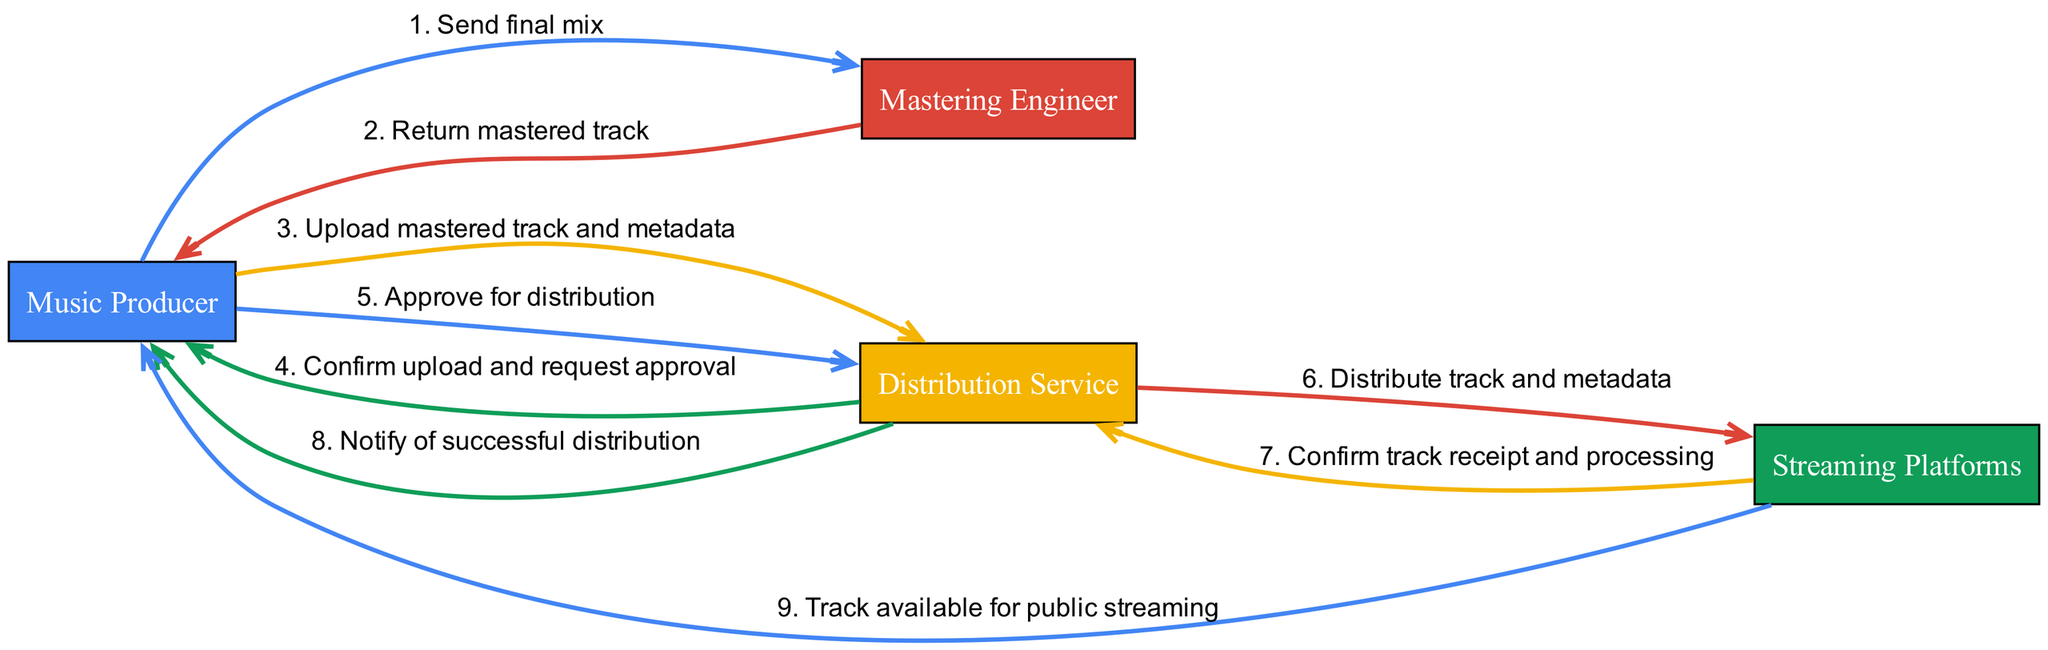What is the first action in the sequence? The first action in the sequence is identified by looking at the first entry in the sequence list. It states that the Music Producer sends the final mix to the Mastering Engineer, marking the beginning of the process.
Answer: Send final mix How many actors are involved in the diagram? To find the number of actors, we can simply count the entries in the "actors" list provided in the data. There are four distinct actors in this diagram.
Answer: 4 Which actor receives the mastered track? By examining the sequence of actions, the second action indicates that the Mastering Engineer sends the mastered track back to the Music Producer. This confirms that the Music Producer is the receiver in this action.
Answer: Music Producer What is the last step before the track is available for streaming? The last step is identified by checking the final action in the sequence. The Streaming Platforms notify the Music Producer that the track is now available for public streaming, which is the final step before it can be accessed by the public.
Answer: Track available for public streaming How many steps are there between sending the final mix and notifying the Music Producer of successful distribution? To determine the number of steps, we can count the actions from when the Music Producer sends the final mix to the point where the Distribution Service notifies the Music Producer of successful distribution. There are five steps in total from start to finish in this flow.
Answer: 5 What does the Distribution Service do after the Music Producer approves for distribution? Looking at the sequence, the Distribution Service distributes the track and metadata to the Streaming Platforms following the approval received from the Music Producer. This confirms the next action taken by the Distribution Service.
Answer: Distribute track and metadata Who sends the mastered track back? The second action in the sequence specifies that the Mastering Engineer returns the mastered track to the Music Producer, indicating their role in this part of the process.
Answer: Mastering Engineer What is the direct relationship between the Distribution Service and Streaming Platforms? The direct relationship is established by the action where the Distribution Service distributes the track and metadata to the Streaming Platforms, highlighting their connection in the workflow of the music distribution.
Answer: Distribute track and metadata What confirmation does the Music Producer receive from the Distribution Service after the upload? The sequence shows that the Distribution Service sends a confirmation back to the Music Producer after the upload, specifically requesting approval before proceeding further, which is a critical communication step in the process.
Answer: Confirm upload and request approval 